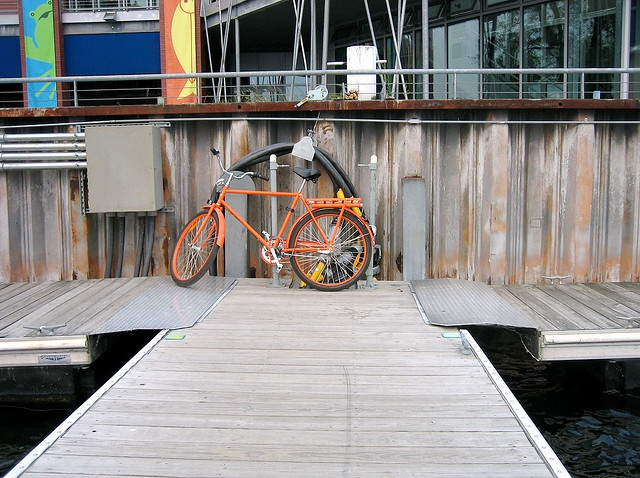Describe the objects in this image and their specific colors. I can see a bicycle in gray, darkgray, salmon, and black tones in this image. 